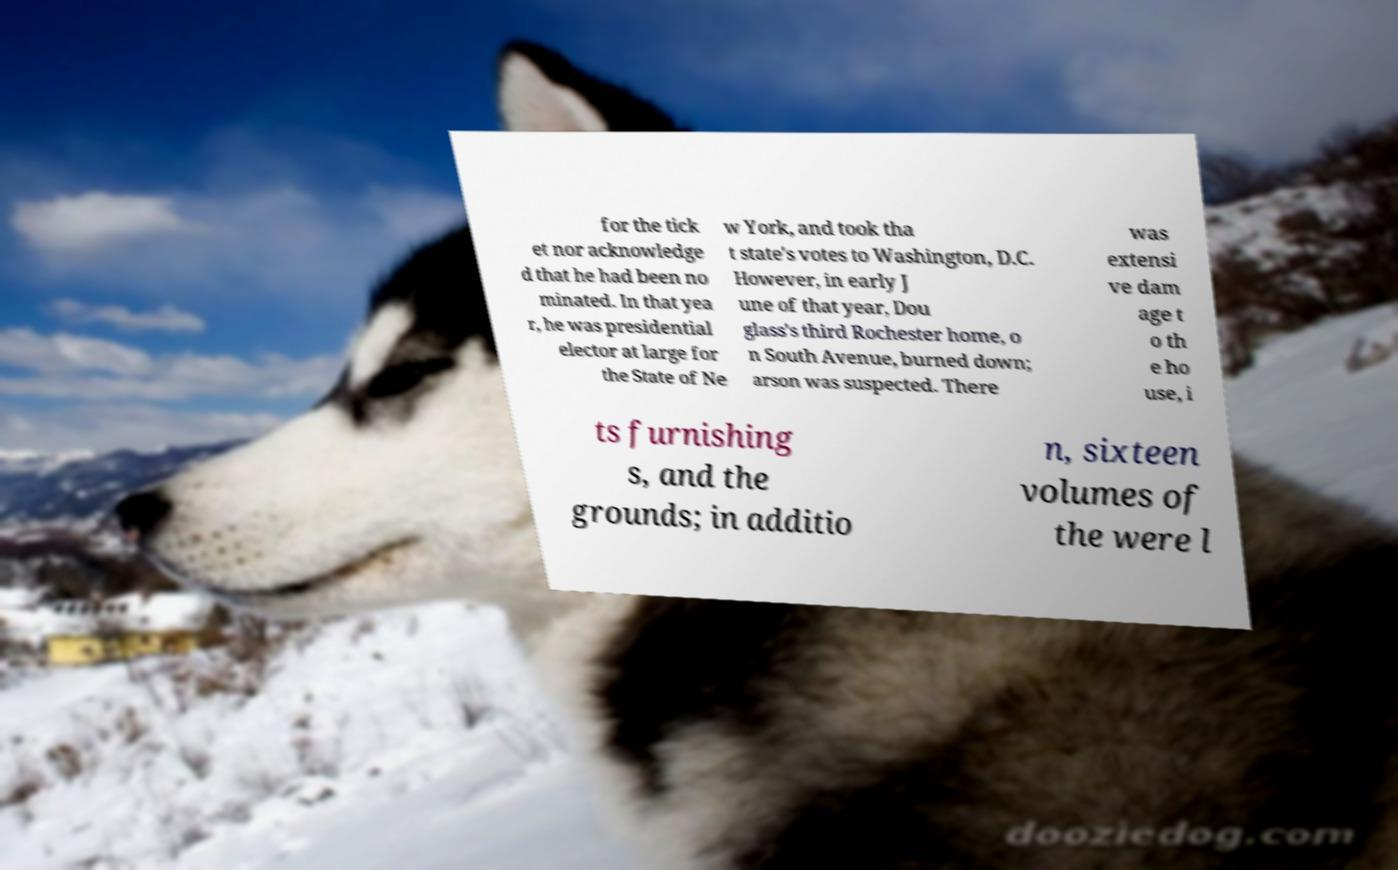I need the written content from this picture converted into text. Can you do that? for the tick et nor acknowledge d that he had been no minated. In that yea r, he was presidential elector at large for the State of Ne w York, and took tha t state's votes to Washington, D.C. However, in early J une of that year, Dou glass's third Rochester home, o n South Avenue, burned down; arson was suspected. There was extensi ve dam age t o th e ho use, i ts furnishing s, and the grounds; in additio n, sixteen volumes of the were l 